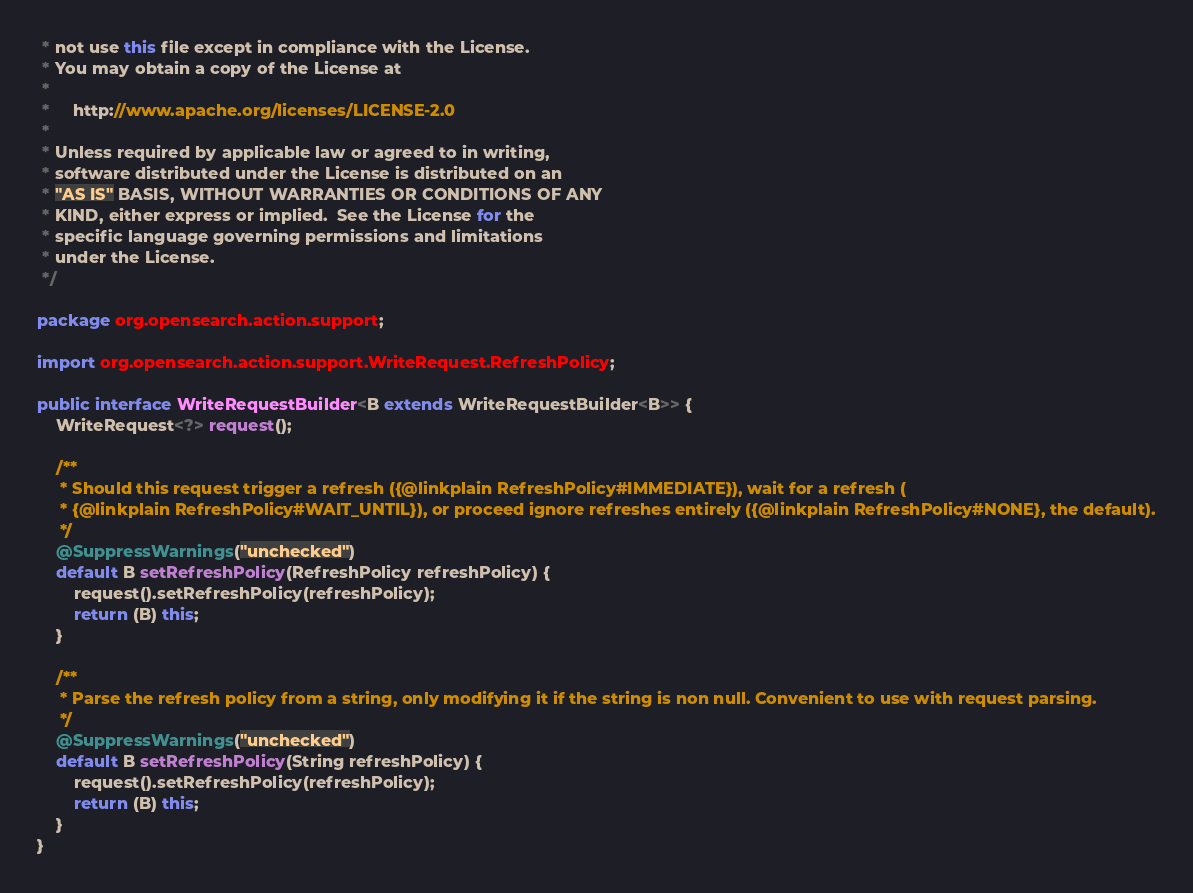Convert code to text. <code><loc_0><loc_0><loc_500><loc_500><_Java_> * not use this file except in compliance with the License.
 * You may obtain a copy of the License at
 *
 *     http://www.apache.org/licenses/LICENSE-2.0
 *
 * Unless required by applicable law or agreed to in writing,
 * software distributed under the License is distributed on an
 * "AS IS" BASIS, WITHOUT WARRANTIES OR CONDITIONS OF ANY
 * KIND, either express or implied.  See the License for the
 * specific language governing permissions and limitations
 * under the License.
 */

package org.opensearch.action.support;

import org.opensearch.action.support.WriteRequest.RefreshPolicy;

public interface WriteRequestBuilder<B extends WriteRequestBuilder<B>> {
    WriteRequest<?> request();

    /**
     * Should this request trigger a refresh ({@linkplain RefreshPolicy#IMMEDIATE}), wait for a refresh (
     * {@linkplain RefreshPolicy#WAIT_UNTIL}), or proceed ignore refreshes entirely ({@linkplain RefreshPolicy#NONE}, the default).
     */
    @SuppressWarnings("unchecked")
    default B setRefreshPolicy(RefreshPolicy refreshPolicy) {
        request().setRefreshPolicy(refreshPolicy);
        return (B) this;
    }

    /**
     * Parse the refresh policy from a string, only modifying it if the string is non null. Convenient to use with request parsing.
     */
    @SuppressWarnings("unchecked")
    default B setRefreshPolicy(String refreshPolicy) {
        request().setRefreshPolicy(refreshPolicy);
        return (B) this;
    }
}
</code> 